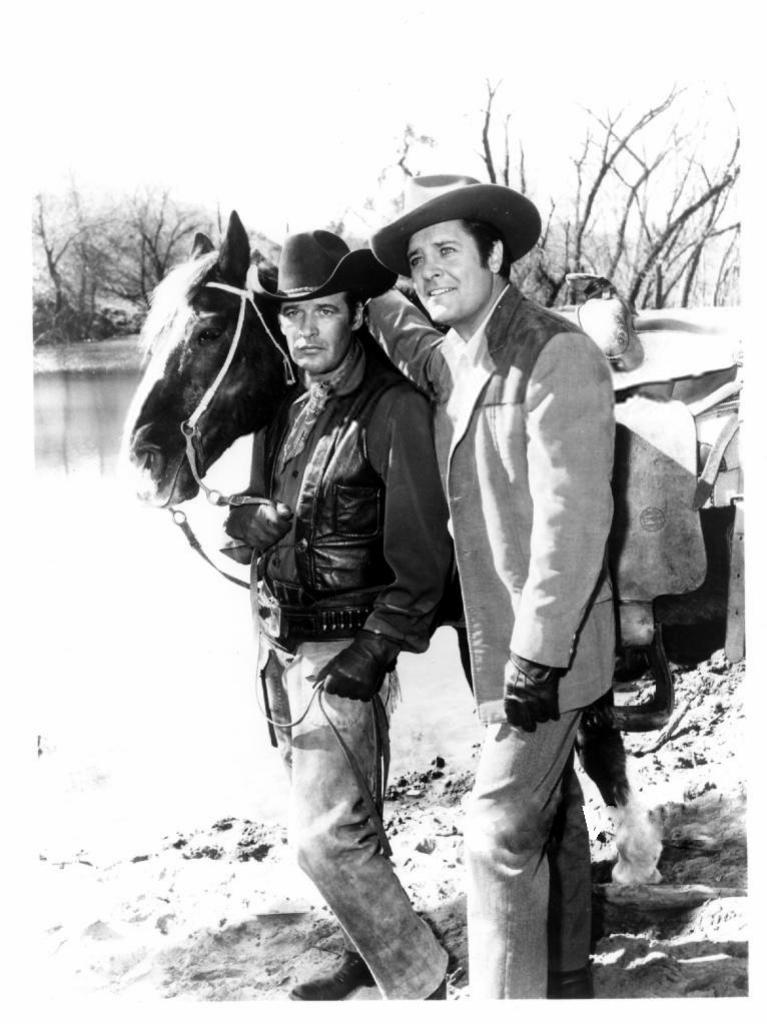What can be seen in the background of the image? There is a sky in the image. What animal is present in the image? There is a horse in the image. What natural element is visible in the image? There is water visible in the image. How many people are in the image? There are two people standing in the image. How does the horse compare to the houses in the image? There are no houses present in the image, so it is not possible to make a comparison between the horse and any houses. 